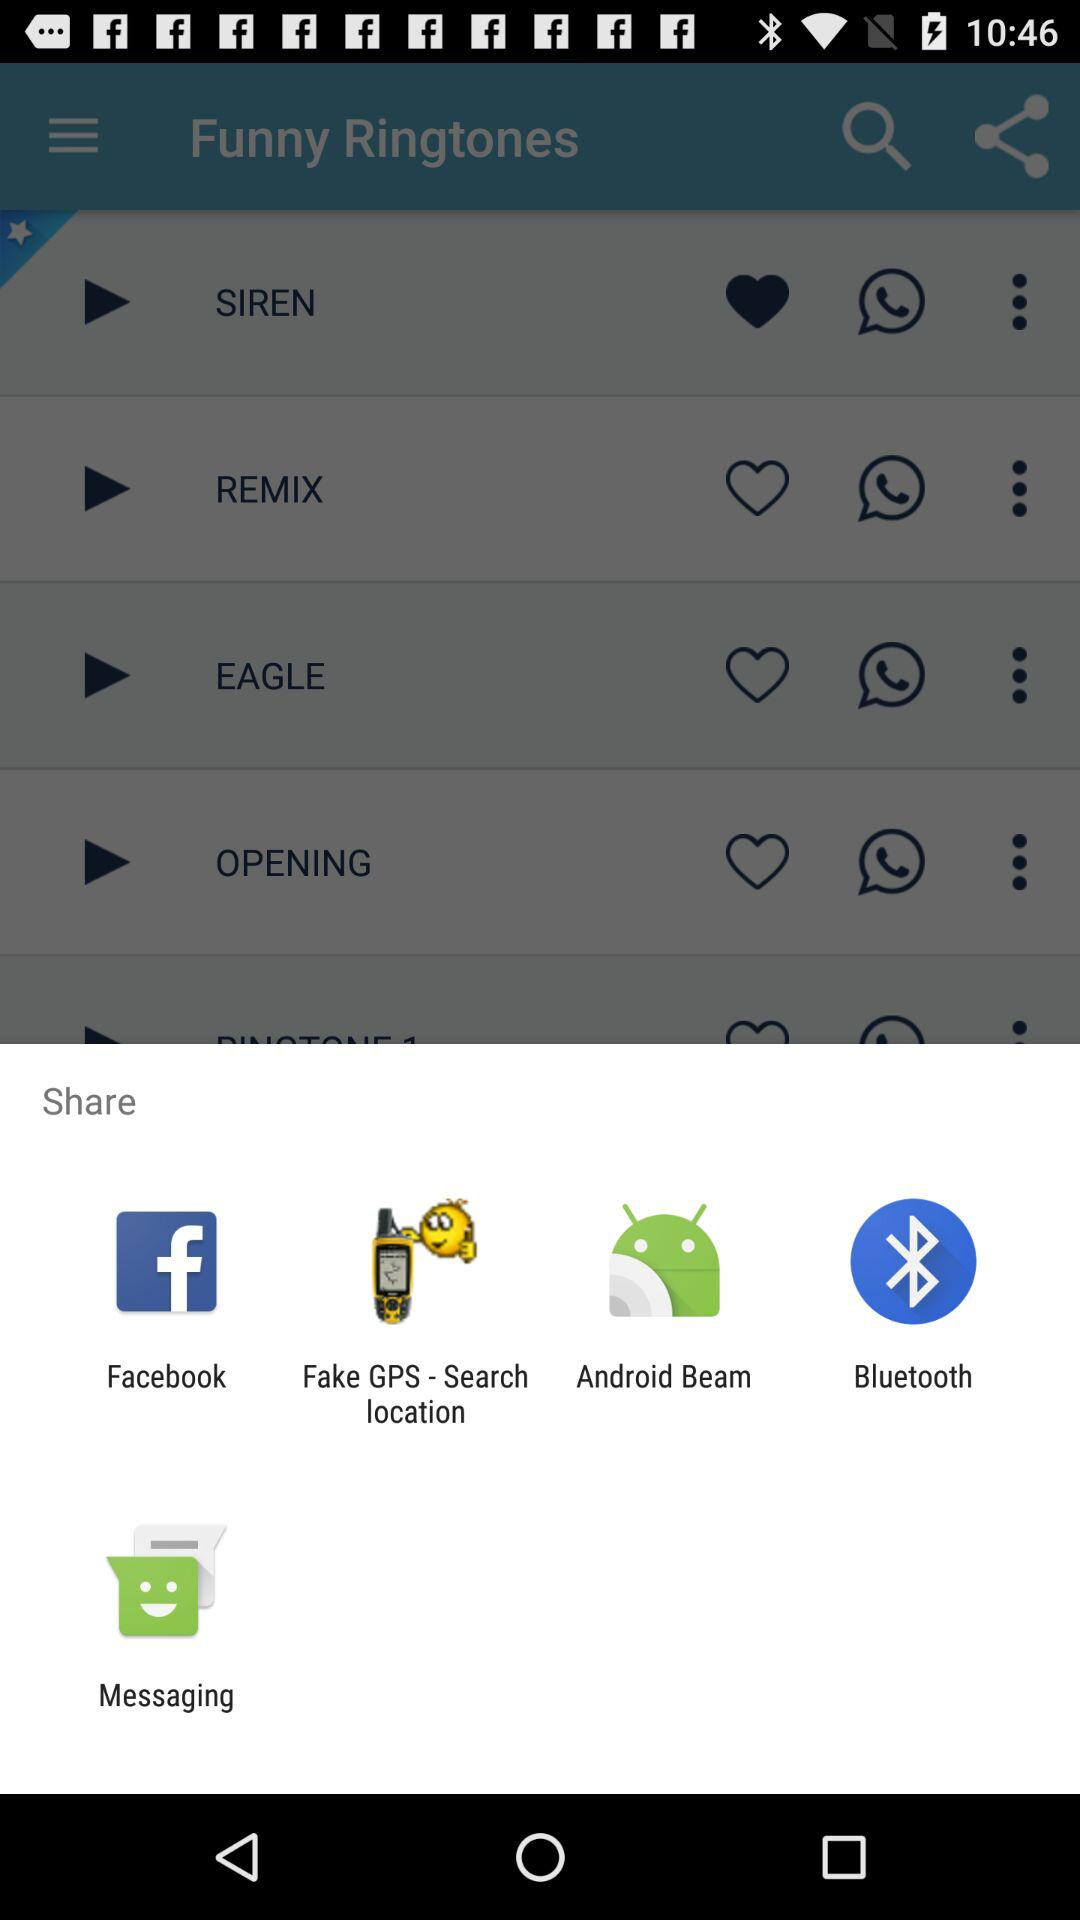What are the other alternatives for sharing? The other alternatives are "Facebook", "Fake GPS - Search location", "Android Beam", "Bluetooth" and "Messaging". 